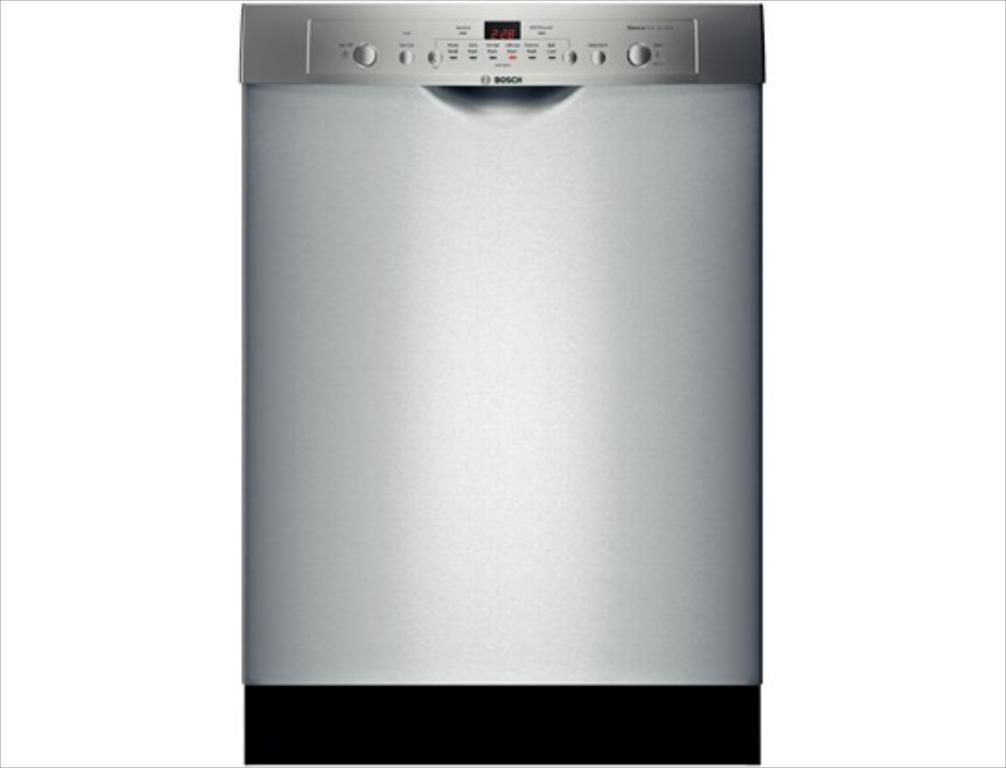What is the main subject of the image? The main subject of the image is a dishwasher. Where is the dishwasher located in the image? The dishwasher is in the center of the image. Are there any words or text on the dishwasher? Yes, there is text on the dishwasher. How does the dishwasher increase the pancake's size in the image? The dishwasher does not increase the pancake's size in the image, as there is no pancake present. Can you see a monkey interacting with the dishwasher in the image? There is no monkey present in the image, so it cannot be interacting with the dishwasher. 